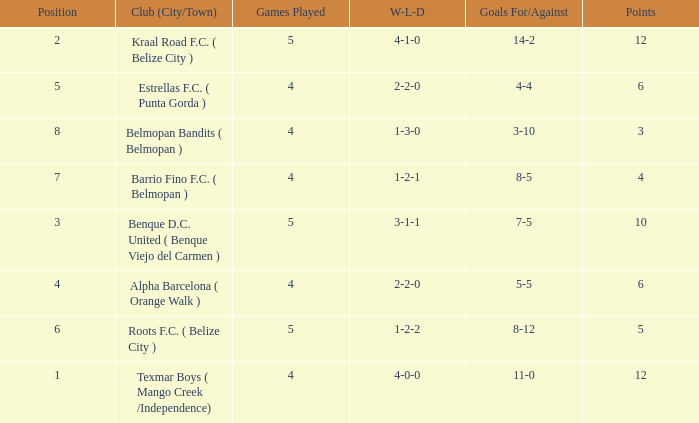What is the minimum points with goals for/against being 8-5 4.0. Could you parse the entire table? {'header': ['Position', 'Club (City/Town)', 'Games Played', 'W-L-D', 'Goals For/Against', 'Points'], 'rows': [['2', 'Kraal Road F.C. ( Belize City )', '5', '4-1-0', '14-2', '12'], ['5', 'Estrellas F.C. ( Punta Gorda )', '4', '2-2-0', '4-4', '6'], ['8', 'Belmopan Bandits ( Belmopan )', '4', '1-3-0', '3-10', '3'], ['7', 'Barrio Fino F.C. ( Belmopan )', '4', '1-2-1', '8-5', '4'], ['3', 'Benque D.C. United ( Benque Viejo del Carmen )', '5', '3-1-1', '7-5', '10'], ['4', 'Alpha Barcelona ( Orange Walk )', '4', '2-2-0', '5-5', '6'], ['6', 'Roots F.C. ( Belize City )', '5', '1-2-2', '8-12', '5'], ['1', 'Texmar Boys ( Mango Creek /Independence)', '4', '4-0-0', '11-0', '12']]} 